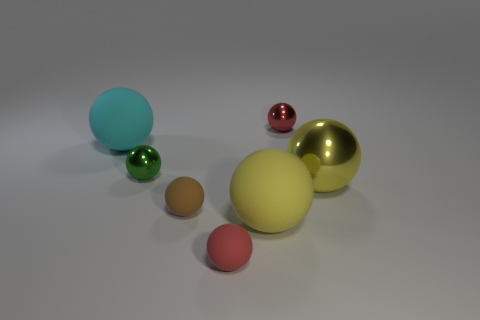What size is the sphere that is behind the small green object and on the right side of the small brown ball?
Your answer should be very brief. Small. There is a red rubber sphere in front of the large yellow sphere right of the big yellow object that is in front of the yellow metallic thing; what size is it?
Give a very brief answer. Small. How many other things are the same color as the big metallic ball?
Your answer should be compact. 1. There is a tiny metallic sphere in front of the tiny red shiny sphere; is its color the same as the large metallic thing?
Ensure brevity in your answer.  No. What number of things are blue metal things or big yellow matte balls?
Provide a short and direct response. 1. There is a big object to the left of the small green sphere; what is its color?
Ensure brevity in your answer.  Cyan. Is the number of tiny brown things that are in front of the tiny red shiny sphere less than the number of tiny brown rubber spheres?
Provide a succinct answer. No. What size is the other ball that is the same color as the large shiny ball?
Provide a short and direct response. Large. Are there any other things that are the same size as the brown thing?
Provide a short and direct response. Yes. Is the material of the tiny brown object the same as the big cyan thing?
Make the answer very short. Yes. 